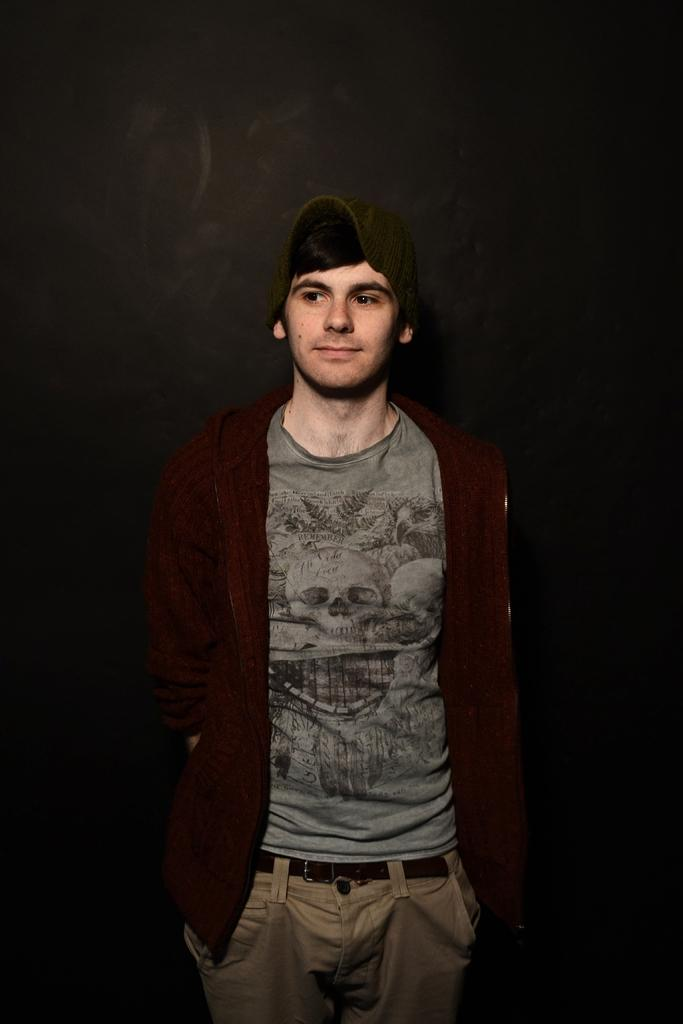What is the main subject of the image? There is a man standing in the center of the image. Can you describe the background of the image? There is a wall in the background of the image. What type of fight is taking place between the band and the brothers in the image? There is no fight, band, or brothers present in the image; it only features a man standing in the center and a wall in the background. 